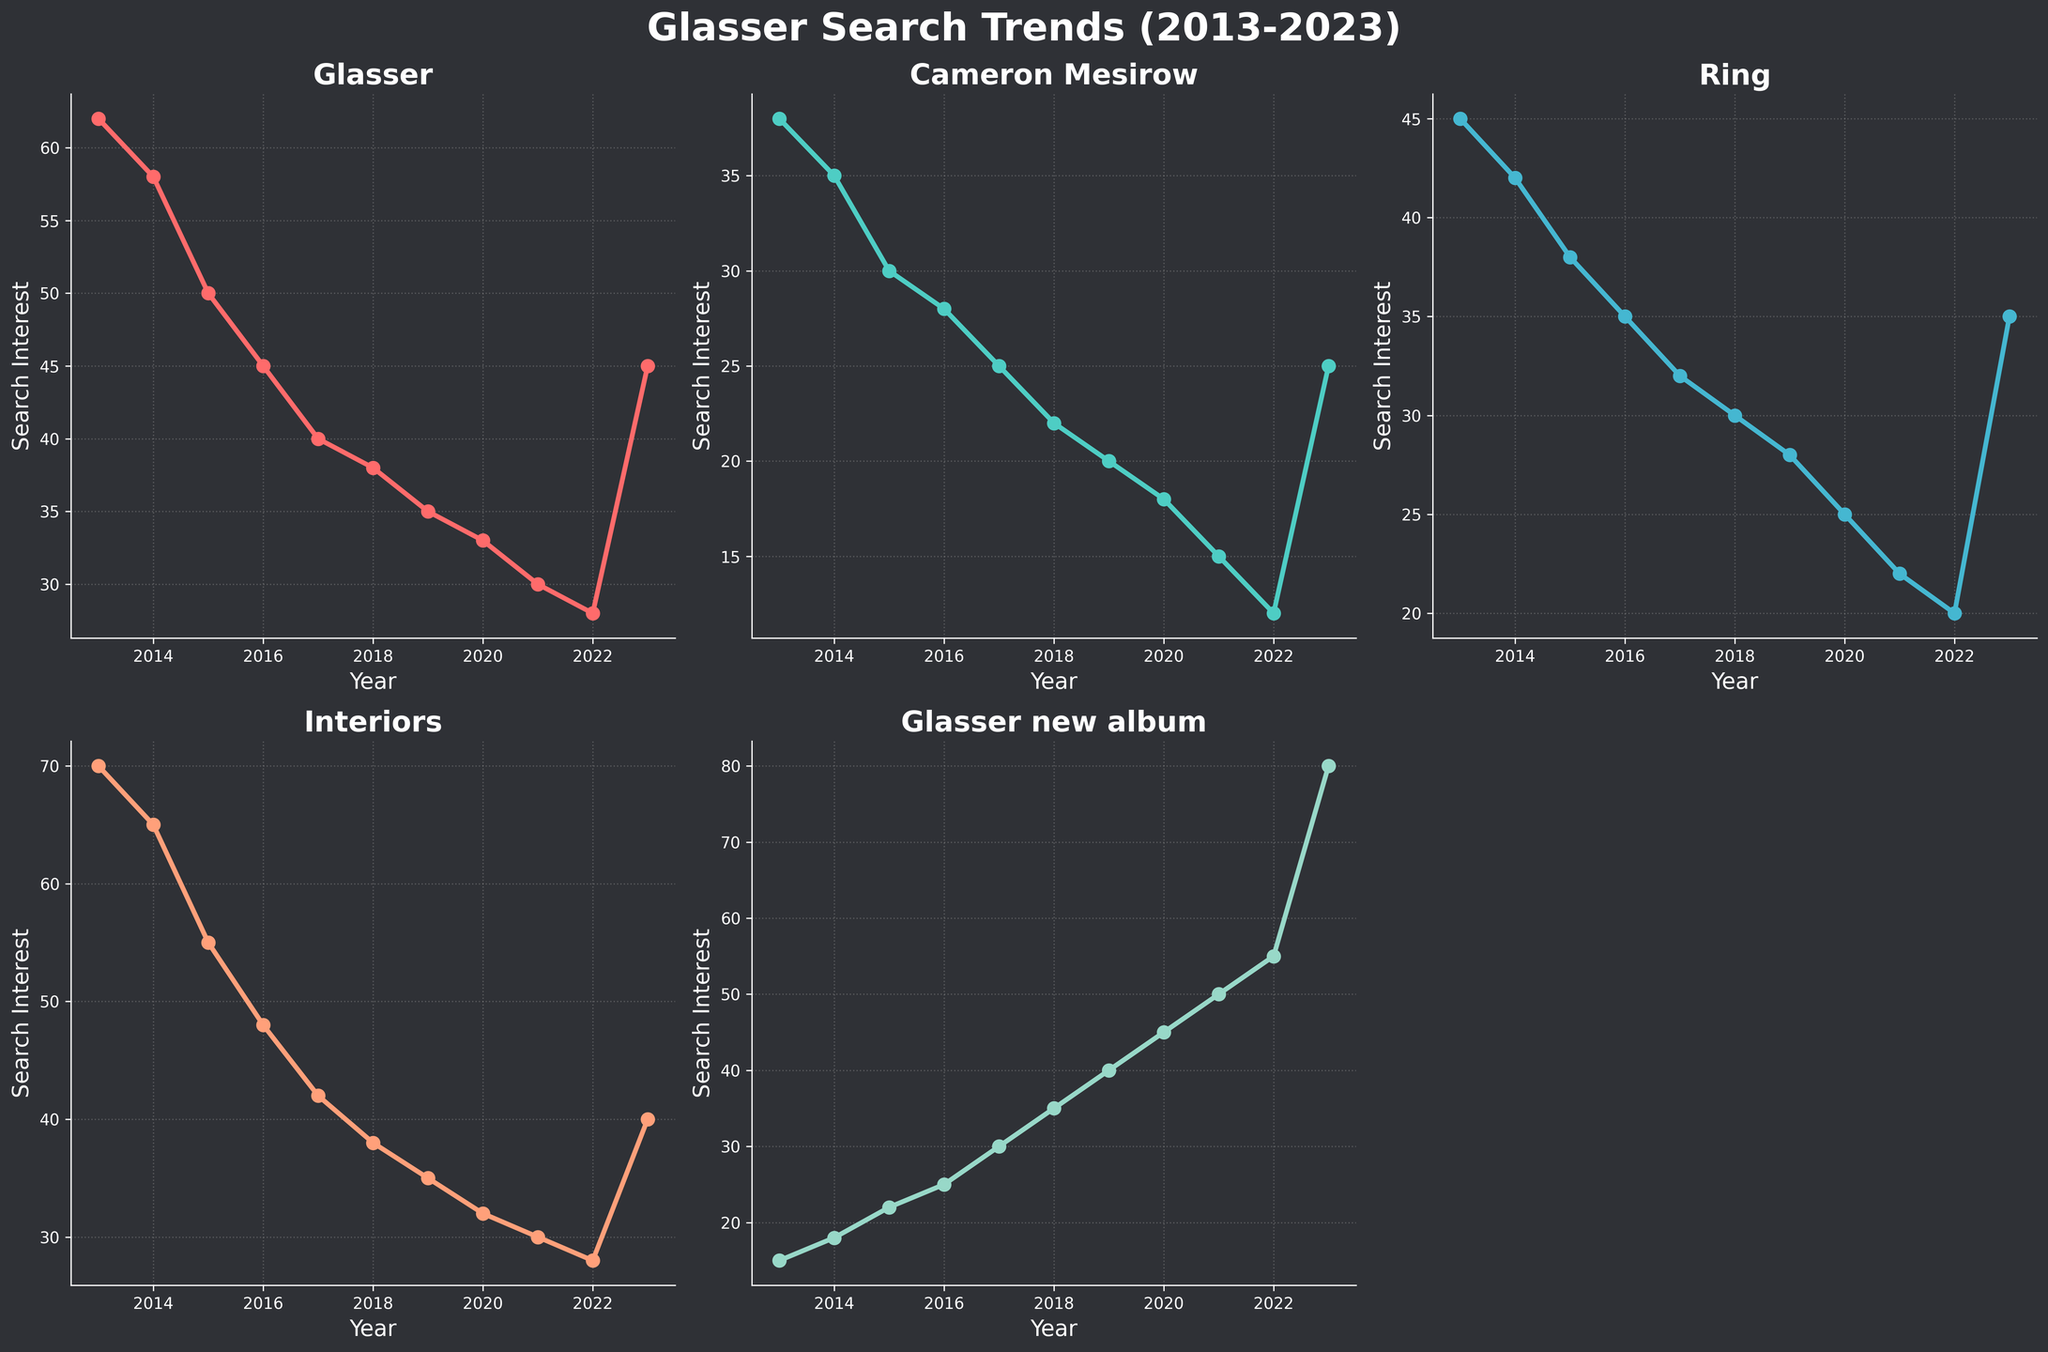How many subplots are there in the figure? The figure consists of a 2x3 grid of subplots, so there are a total of 6 subplots. However, one of them is empty, leaving us with 5 filled subplots.
Answer: 5 What's the highest search interest value for "Glasser new album" and in which year did it occur? The highest search interest for "Glasser new album" is 80, which occurred in 2023.
Answer: 80 in 2023 Which keyword had the highest search interest in 2013? By examining the y-axes of the individual subplots, "Interiors" had the highest search interest in 2013 with a value of 70.
Answer: Interiors Between 2017 and 2022, which keyword showed the highest increase in search interest? By comparing the differences in search interests from 2017 to 2022, "Glasser new album" increased by 25 (30 to 55) which is the highest among all keywords.
Answer: Glasser new album In which year did "Ring" and "Interiors" have the same search interest value? And what is that value? Both "Ring" and "Interiors" had a search interest of 28 in 2022.
Answer: 2022, 28 What is the trend for "Cameron Mesirow" from 2013 to 2023? The line chart for "Cameron Mesirow" indicates a general downward trend from 38 in 2013 to 12 in 2022, followed by an increase to 25 in 2023.
Answer: Generally downward followed by a slight increase How does the search interest for "Glasser" in 2023 compare to that in 2013? "Glasser" had a search interest of 62 in 2013 and 45 in 2023, showing a decrease of 17 points over the decade.
Answer: Decreased by 17 What year did "Interiors" see the most significant drop in search interest and how much was the decrease? The most significant drop for "Interiors" occurred between 2013 (70) and 2014 (65), with a decrease of 5 points.
Answer: 2014, 5 On which subplot is the search interest line mostly horizontal? The subplot for "Ring" shows the most horizontal line indicating relatively stable search interest over the years, with only gradual declines.
Answer: Ring 